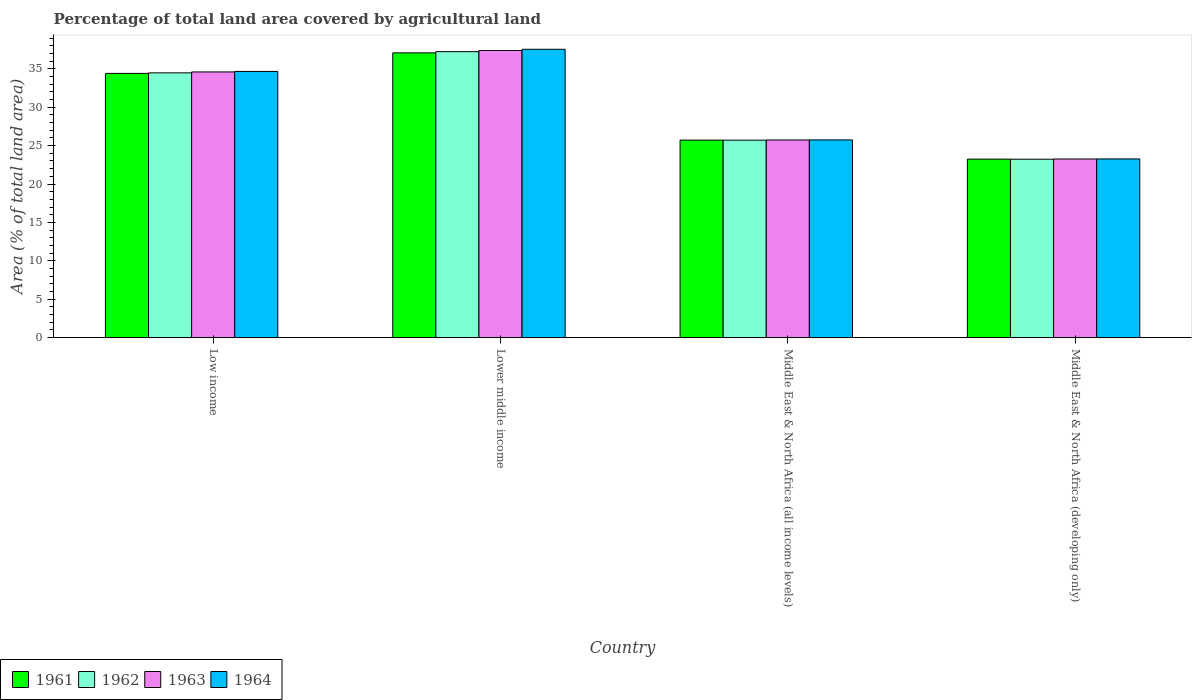Are the number of bars per tick equal to the number of legend labels?
Make the answer very short. Yes. Are the number of bars on each tick of the X-axis equal?
Keep it short and to the point. Yes. How many bars are there on the 1st tick from the right?
Give a very brief answer. 4. What is the label of the 3rd group of bars from the left?
Your response must be concise. Middle East & North Africa (all income levels). In how many cases, is the number of bars for a given country not equal to the number of legend labels?
Your answer should be compact. 0. What is the percentage of agricultural land in 1962 in Middle East & North Africa (developing only)?
Make the answer very short. 23.23. Across all countries, what is the maximum percentage of agricultural land in 1961?
Offer a very short reply. 37.07. Across all countries, what is the minimum percentage of agricultural land in 1961?
Your response must be concise. 23.24. In which country was the percentage of agricultural land in 1961 maximum?
Provide a succinct answer. Lower middle income. In which country was the percentage of agricultural land in 1961 minimum?
Offer a terse response. Middle East & North Africa (developing only). What is the total percentage of agricultural land in 1964 in the graph?
Offer a very short reply. 121.2. What is the difference between the percentage of agricultural land in 1961 in Lower middle income and that in Middle East & North Africa (developing only)?
Your response must be concise. 13.83. What is the difference between the percentage of agricultural land in 1963 in Low income and the percentage of agricultural land in 1961 in Middle East & North Africa (developing only)?
Offer a very short reply. 11.35. What is the average percentage of agricultural land in 1963 per country?
Offer a very short reply. 30.24. What is the difference between the percentage of agricultural land of/in 1962 and percentage of agricultural land of/in 1964 in Middle East & North Africa (all income levels)?
Your response must be concise. -0.03. In how many countries, is the percentage of agricultural land in 1963 greater than 23 %?
Offer a terse response. 4. What is the ratio of the percentage of agricultural land in 1964 in Low income to that in Middle East & North Africa (developing only)?
Your answer should be very brief. 1.49. Is the difference between the percentage of agricultural land in 1962 in Low income and Middle East & North Africa (all income levels) greater than the difference between the percentage of agricultural land in 1964 in Low income and Middle East & North Africa (all income levels)?
Keep it short and to the point. No. What is the difference between the highest and the second highest percentage of agricultural land in 1961?
Provide a short and direct response. -8.68. What is the difference between the highest and the lowest percentage of agricultural land in 1964?
Your answer should be compact. 14.27. In how many countries, is the percentage of agricultural land in 1963 greater than the average percentage of agricultural land in 1963 taken over all countries?
Your response must be concise. 2. Is the sum of the percentage of agricultural land in 1963 in Low income and Middle East & North Africa (all income levels) greater than the maximum percentage of agricultural land in 1961 across all countries?
Your answer should be compact. Yes. Is it the case that in every country, the sum of the percentage of agricultural land in 1964 and percentage of agricultural land in 1963 is greater than the sum of percentage of agricultural land in 1961 and percentage of agricultural land in 1962?
Give a very brief answer. No. What does the 1st bar from the left in Middle East & North Africa (all income levels) represents?
Keep it short and to the point. 1961. What does the 3rd bar from the right in Middle East & North Africa (all income levels) represents?
Your answer should be compact. 1962. Is it the case that in every country, the sum of the percentage of agricultural land in 1964 and percentage of agricultural land in 1962 is greater than the percentage of agricultural land in 1961?
Give a very brief answer. Yes. What is the difference between two consecutive major ticks on the Y-axis?
Your answer should be compact. 5. Are the values on the major ticks of Y-axis written in scientific E-notation?
Your response must be concise. No. Does the graph contain any zero values?
Ensure brevity in your answer.  No. Where does the legend appear in the graph?
Give a very brief answer. Bottom left. What is the title of the graph?
Your response must be concise. Percentage of total land area covered by agricultural land. What is the label or title of the Y-axis?
Give a very brief answer. Area (% of total land area). What is the Area (% of total land area) in 1961 in Low income?
Ensure brevity in your answer.  34.4. What is the Area (% of total land area) of 1962 in Low income?
Your response must be concise. 34.47. What is the Area (% of total land area) of 1963 in Low income?
Your answer should be compact. 34.59. What is the Area (% of total land area) of 1964 in Low income?
Your answer should be very brief. 34.66. What is the Area (% of total land area) in 1961 in Lower middle income?
Your response must be concise. 37.07. What is the Area (% of total land area) in 1962 in Lower middle income?
Your answer should be very brief. 37.23. What is the Area (% of total land area) in 1963 in Lower middle income?
Provide a succinct answer. 37.38. What is the Area (% of total land area) in 1964 in Lower middle income?
Keep it short and to the point. 37.54. What is the Area (% of total land area) of 1961 in Middle East & North Africa (all income levels)?
Your answer should be compact. 25.72. What is the Area (% of total land area) in 1962 in Middle East & North Africa (all income levels)?
Provide a short and direct response. 25.71. What is the Area (% of total land area) of 1963 in Middle East & North Africa (all income levels)?
Ensure brevity in your answer.  25.73. What is the Area (% of total land area) of 1964 in Middle East & North Africa (all income levels)?
Offer a very short reply. 25.74. What is the Area (% of total land area) of 1961 in Middle East & North Africa (developing only)?
Offer a very short reply. 23.24. What is the Area (% of total land area) of 1962 in Middle East & North Africa (developing only)?
Keep it short and to the point. 23.23. What is the Area (% of total land area) in 1963 in Middle East & North Africa (developing only)?
Your answer should be very brief. 23.26. What is the Area (% of total land area) of 1964 in Middle East & North Africa (developing only)?
Keep it short and to the point. 23.26. Across all countries, what is the maximum Area (% of total land area) of 1961?
Your response must be concise. 37.07. Across all countries, what is the maximum Area (% of total land area) in 1962?
Offer a very short reply. 37.23. Across all countries, what is the maximum Area (% of total land area) of 1963?
Keep it short and to the point. 37.38. Across all countries, what is the maximum Area (% of total land area) of 1964?
Your answer should be very brief. 37.54. Across all countries, what is the minimum Area (% of total land area) in 1961?
Make the answer very short. 23.24. Across all countries, what is the minimum Area (% of total land area) of 1962?
Ensure brevity in your answer.  23.23. Across all countries, what is the minimum Area (% of total land area) in 1963?
Your answer should be very brief. 23.26. Across all countries, what is the minimum Area (% of total land area) of 1964?
Provide a succinct answer. 23.26. What is the total Area (% of total land area) of 1961 in the graph?
Your response must be concise. 120.43. What is the total Area (% of total land area) in 1962 in the graph?
Your answer should be compact. 120.64. What is the total Area (% of total land area) in 1963 in the graph?
Make the answer very short. 120.96. What is the total Area (% of total land area) in 1964 in the graph?
Make the answer very short. 121.2. What is the difference between the Area (% of total land area) in 1961 in Low income and that in Lower middle income?
Offer a terse response. -2.67. What is the difference between the Area (% of total land area) in 1962 in Low income and that in Lower middle income?
Offer a very short reply. -2.77. What is the difference between the Area (% of total land area) in 1963 in Low income and that in Lower middle income?
Your answer should be very brief. -2.79. What is the difference between the Area (% of total land area) in 1964 in Low income and that in Lower middle income?
Keep it short and to the point. -2.88. What is the difference between the Area (% of total land area) of 1961 in Low income and that in Middle East & North Africa (all income levels)?
Ensure brevity in your answer.  8.68. What is the difference between the Area (% of total land area) of 1962 in Low income and that in Middle East & North Africa (all income levels)?
Keep it short and to the point. 8.76. What is the difference between the Area (% of total land area) of 1963 in Low income and that in Middle East & North Africa (all income levels)?
Keep it short and to the point. 8.85. What is the difference between the Area (% of total land area) of 1964 in Low income and that in Middle East & North Africa (all income levels)?
Offer a very short reply. 8.91. What is the difference between the Area (% of total land area) in 1961 in Low income and that in Middle East & North Africa (developing only)?
Provide a succinct answer. 11.16. What is the difference between the Area (% of total land area) of 1962 in Low income and that in Middle East & North Africa (developing only)?
Ensure brevity in your answer.  11.24. What is the difference between the Area (% of total land area) of 1963 in Low income and that in Middle East & North Africa (developing only)?
Give a very brief answer. 11.33. What is the difference between the Area (% of total land area) in 1964 in Low income and that in Middle East & North Africa (developing only)?
Your answer should be very brief. 11.39. What is the difference between the Area (% of total land area) of 1961 in Lower middle income and that in Middle East & North Africa (all income levels)?
Offer a terse response. 11.36. What is the difference between the Area (% of total land area) of 1962 in Lower middle income and that in Middle East & North Africa (all income levels)?
Offer a terse response. 11.52. What is the difference between the Area (% of total land area) of 1963 in Lower middle income and that in Middle East & North Africa (all income levels)?
Your response must be concise. 11.65. What is the difference between the Area (% of total land area) in 1964 in Lower middle income and that in Middle East & North Africa (all income levels)?
Your answer should be very brief. 11.8. What is the difference between the Area (% of total land area) of 1961 in Lower middle income and that in Middle East & North Africa (developing only)?
Your answer should be compact. 13.83. What is the difference between the Area (% of total land area) in 1962 in Lower middle income and that in Middle East & North Africa (developing only)?
Make the answer very short. 14. What is the difference between the Area (% of total land area) in 1963 in Lower middle income and that in Middle East & North Africa (developing only)?
Your response must be concise. 14.12. What is the difference between the Area (% of total land area) in 1964 in Lower middle income and that in Middle East & North Africa (developing only)?
Provide a succinct answer. 14.27. What is the difference between the Area (% of total land area) of 1961 in Middle East & North Africa (all income levels) and that in Middle East & North Africa (developing only)?
Your answer should be very brief. 2.48. What is the difference between the Area (% of total land area) in 1962 in Middle East & North Africa (all income levels) and that in Middle East & North Africa (developing only)?
Offer a very short reply. 2.48. What is the difference between the Area (% of total land area) of 1963 in Middle East & North Africa (all income levels) and that in Middle East & North Africa (developing only)?
Your answer should be compact. 2.48. What is the difference between the Area (% of total land area) in 1964 in Middle East & North Africa (all income levels) and that in Middle East & North Africa (developing only)?
Provide a short and direct response. 2.48. What is the difference between the Area (% of total land area) in 1961 in Low income and the Area (% of total land area) in 1962 in Lower middle income?
Your response must be concise. -2.83. What is the difference between the Area (% of total land area) in 1961 in Low income and the Area (% of total land area) in 1963 in Lower middle income?
Your response must be concise. -2.98. What is the difference between the Area (% of total land area) in 1961 in Low income and the Area (% of total land area) in 1964 in Lower middle income?
Provide a short and direct response. -3.14. What is the difference between the Area (% of total land area) of 1962 in Low income and the Area (% of total land area) of 1963 in Lower middle income?
Keep it short and to the point. -2.91. What is the difference between the Area (% of total land area) of 1962 in Low income and the Area (% of total land area) of 1964 in Lower middle income?
Make the answer very short. -3.07. What is the difference between the Area (% of total land area) in 1963 in Low income and the Area (% of total land area) in 1964 in Lower middle income?
Your answer should be compact. -2.95. What is the difference between the Area (% of total land area) in 1961 in Low income and the Area (% of total land area) in 1962 in Middle East & North Africa (all income levels)?
Keep it short and to the point. 8.69. What is the difference between the Area (% of total land area) in 1961 in Low income and the Area (% of total land area) in 1963 in Middle East & North Africa (all income levels)?
Offer a very short reply. 8.67. What is the difference between the Area (% of total land area) in 1961 in Low income and the Area (% of total land area) in 1964 in Middle East & North Africa (all income levels)?
Offer a terse response. 8.66. What is the difference between the Area (% of total land area) in 1962 in Low income and the Area (% of total land area) in 1963 in Middle East & North Africa (all income levels)?
Give a very brief answer. 8.73. What is the difference between the Area (% of total land area) of 1962 in Low income and the Area (% of total land area) of 1964 in Middle East & North Africa (all income levels)?
Offer a terse response. 8.73. What is the difference between the Area (% of total land area) of 1963 in Low income and the Area (% of total land area) of 1964 in Middle East & North Africa (all income levels)?
Give a very brief answer. 8.85. What is the difference between the Area (% of total land area) of 1961 in Low income and the Area (% of total land area) of 1962 in Middle East & North Africa (developing only)?
Ensure brevity in your answer.  11.17. What is the difference between the Area (% of total land area) in 1961 in Low income and the Area (% of total land area) in 1963 in Middle East & North Africa (developing only)?
Give a very brief answer. 11.14. What is the difference between the Area (% of total land area) in 1961 in Low income and the Area (% of total land area) in 1964 in Middle East & North Africa (developing only)?
Make the answer very short. 11.14. What is the difference between the Area (% of total land area) in 1962 in Low income and the Area (% of total land area) in 1963 in Middle East & North Africa (developing only)?
Your answer should be very brief. 11.21. What is the difference between the Area (% of total land area) in 1962 in Low income and the Area (% of total land area) in 1964 in Middle East & North Africa (developing only)?
Provide a short and direct response. 11.2. What is the difference between the Area (% of total land area) in 1963 in Low income and the Area (% of total land area) in 1964 in Middle East & North Africa (developing only)?
Offer a terse response. 11.32. What is the difference between the Area (% of total land area) of 1961 in Lower middle income and the Area (% of total land area) of 1962 in Middle East & North Africa (all income levels)?
Offer a very short reply. 11.36. What is the difference between the Area (% of total land area) of 1961 in Lower middle income and the Area (% of total land area) of 1963 in Middle East & North Africa (all income levels)?
Provide a succinct answer. 11.34. What is the difference between the Area (% of total land area) of 1961 in Lower middle income and the Area (% of total land area) of 1964 in Middle East & North Africa (all income levels)?
Offer a terse response. 11.33. What is the difference between the Area (% of total land area) of 1962 in Lower middle income and the Area (% of total land area) of 1963 in Middle East & North Africa (all income levels)?
Make the answer very short. 11.5. What is the difference between the Area (% of total land area) in 1962 in Lower middle income and the Area (% of total land area) in 1964 in Middle East & North Africa (all income levels)?
Offer a very short reply. 11.49. What is the difference between the Area (% of total land area) in 1963 in Lower middle income and the Area (% of total land area) in 1964 in Middle East & North Africa (all income levels)?
Your answer should be very brief. 11.64. What is the difference between the Area (% of total land area) of 1961 in Lower middle income and the Area (% of total land area) of 1962 in Middle East & North Africa (developing only)?
Your response must be concise. 13.85. What is the difference between the Area (% of total land area) of 1961 in Lower middle income and the Area (% of total land area) of 1963 in Middle East & North Africa (developing only)?
Make the answer very short. 13.82. What is the difference between the Area (% of total land area) in 1961 in Lower middle income and the Area (% of total land area) in 1964 in Middle East & North Africa (developing only)?
Provide a succinct answer. 13.81. What is the difference between the Area (% of total land area) of 1962 in Lower middle income and the Area (% of total land area) of 1963 in Middle East & North Africa (developing only)?
Your response must be concise. 13.98. What is the difference between the Area (% of total land area) in 1962 in Lower middle income and the Area (% of total land area) in 1964 in Middle East & North Africa (developing only)?
Offer a terse response. 13.97. What is the difference between the Area (% of total land area) of 1963 in Lower middle income and the Area (% of total land area) of 1964 in Middle East & North Africa (developing only)?
Give a very brief answer. 14.12. What is the difference between the Area (% of total land area) of 1961 in Middle East & North Africa (all income levels) and the Area (% of total land area) of 1962 in Middle East & North Africa (developing only)?
Your answer should be very brief. 2.49. What is the difference between the Area (% of total land area) of 1961 in Middle East & North Africa (all income levels) and the Area (% of total land area) of 1963 in Middle East & North Africa (developing only)?
Offer a very short reply. 2.46. What is the difference between the Area (% of total land area) in 1961 in Middle East & North Africa (all income levels) and the Area (% of total land area) in 1964 in Middle East & North Africa (developing only)?
Offer a very short reply. 2.45. What is the difference between the Area (% of total land area) in 1962 in Middle East & North Africa (all income levels) and the Area (% of total land area) in 1963 in Middle East & North Africa (developing only)?
Your answer should be very brief. 2.45. What is the difference between the Area (% of total land area) of 1962 in Middle East & North Africa (all income levels) and the Area (% of total land area) of 1964 in Middle East & North Africa (developing only)?
Provide a short and direct response. 2.45. What is the difference between the Area (% of total land area) of 1963 in Middle East & North Africa (all income levels) and the Area (% of total land area) of 1964 in Middle East & North Africa (developing only)?
Make the answer very short. 2.47. What is the average Area (% of total land area) in 1961 per country?
Your answer should be compact. 30.11. What is the average Area (% of total land area) in 1962 per country?
Your answer should be very brief. 30.16. What is the average Area (% of total land area) of 1963 per country?
Give a very brief answer. 30.24. What is the average Area (% of total land area) of 1964 per country?
Your response must be concise. 30.3. What is the difference between the Area (% of total land area) in 1961 and Area (% of total land area) in 1962 in Low income?
Your answer should be compact. -0.07. What is the difference between the Area (% of total land area) of 1961 and Area (% of total land area) of 1963 in Low income?
Provide a succinct answer. -0.19. What is the difference between the Area (% of total land area) of 1961 and Area (% of total land area) of 1964 in Low income?
Offer a very short reply. -0.26. What is the difference between the Area (% of total land area) of 1962 and Area (% of total land area) of 1963 in Low income?
Make the answer very short. -0.12. What is the difference between the Area (% of total land area) in 1962 and Area (% of total land area) in 1964 in Low income?
Your answer should be compact. -0.19. What is the difference between the Area (% of total land area) of 1963 and Area (% of total land area) of 1964 in Low income?
Keep it short and to the point. -0.07. What is the difference between the Area (% of total land area) in 1961 and Area (% of total land area) in 1962 in Lower middle income?
Your response must be concise. -0.16. What is the difference between the Area (% of total land area) in 1961 and Area (% of total land area) in 1963 in Lower middle income?
Your answer should be very brief. -0.31. What is the difference between the Area (% of total land area) in 1961 and Area (% of total land area) in 1964 in Lower middle income?
Provide a succinct answer. -0.46. What is the difference between the Area (% of total land area) of 1962 and Area (% of total land area) of 1963 in Lower middle income?
Your answer should be compact. -0.15. What is the difference between the Area (% of total land area) in 1962 and Area (% of total land area) in 1964 in Lower middle income?
Make the answer very short. -0.3. What is the difference between the Area (% of total land area) of 1963 and Area (% of total land area) of 1964 in Lower middle income?
Offer a very short reply. -0.16. What is the difference between the Area (% of total land area) of 1961 and Area (% of total land area) of 1962 in Middle East & North Africa (all income levels)?
Your answer should be very brief. 0.01. What is the difference between the Area (% of total land area) of 1961 and Area (% of total land area) of 1963 in Middle East & North Africa (all income levels)?
Keep it short and to the point. -0.02. What is the difference between the Area (% of total land area) of 1961 and Area (% of total land area) of 1964 in Middle East & North Africa (all income levels)?
Ensure brevity in your answer.  -0.02. What is the difference between the Area (% of total land area) in 1962 and Area (% of total land area) in 1963 in Middle East & North Africa (all income levels)?
Make the answer very short. -0.03. What is the difference between the Area (% of total land area) in 1962 and Area (% of total land area) in 1964 in Middle East & North Africa (all income levels)?
Give a very brief answer. -0.03. What is the difference between the Area (% of total land area) in 1963 and Area (% of total land area) in 1964 in Middle East & North Africa (all income levels)?
Make the answer very short. -0.01. What is the difference between the Area (% of total land area) of 1961 and Area (% of total land area) of 1962 in Middle East & North Africa (developing only)?
Provide a short and direct response. 0.01. What is the difference between the Area (% of total land area) in 1961 and Area (% of total land area) in 1963 in Middle East & North Africa (developing only)?
Your answer should be very brief. -0.02. What is the difference between the Area (% of total land area) in 1961 and Area (% of total land area) in 1964 in Middle East & North Africa (developing only)?
Your response must be concise. -0.02. What is the difference between the Area (% of total land area) of 1962 and Area (% of total land area) of 1963 in Middle East & North Africa (developing only)?
Provide a succinct answer. -0.03. What is the difference between the Area (% of total land area) of 1962 and Area (% of total land area) of 1964 in Middle East & North Africa (developing only)?
Give a very brief answer. -0.03. What is the difference between the Area (% of total land area) of 1963 and Area (% of total land area) of 1964 in Middle East & North Africa (developing only)?
Your response must be concise. -0.01. What is the ratio of the Area (% of total land area) of 1961 in Low income to that in Lower middle income?
Your response must be concise. 0.93. What is the ratio of the Area (% of total land area) in 1962 in Low income to that in Lower middle income?
Offer a very short reply. 0.93. What is the ratio of the Area (% of total land area) in 1963 in Low income to that in Lower middle income?
Make the answer very short. 0.93. What is the ratio of the Area (% of total land area) of 1964 in Low income to that in Lower middle income?
Ensure brevity in your answer.  0.92. What is the ratio of the Area (% of total land area) in 1961 in Low income to that in Middle East & North Africa (all income levels)?
Keep it short and to the point. 1.34. What is the ratio of the Area (% of total land area) in 1962 in Low income to that in Middle East & North Africa (all income levels)?
Keep it short and to the point. 1.34. What is the ratio of the Area (% of total land area) in 1963 in Low income to that in Middle East & North Africa (all income levels)?
Provide a succinct answer. 1.34. What is the ratio of the Area (% of total land area) of 1964 in Low income to that in Middle East & North Africa (all income levels)?
Make the answer very short. 1.35. What is the ratio of the Area (% of total land area) in 1961 in Low income to that in Middle East & North Africa (developing only)?
Keep it short and to the point. 1.48. What is the ratio of the Area (% of total land area) of 1962 in Low income to that in Middle East & North Africa (developing only)?
Ensure brevity in your answer.  1.48. What is the ratio of the Area (% of total land area) in 1963 in Low income to that in Middle East & North Africa (developing only)?
Your answer should be very brief. 1.49. What is the ratio of the Area (% of total land area) of 1964 in Low income to that in Middle East & North Africa (developing only)?
Your answer should be compact. 1.49. What is the ratio of the Area (% of total land area) in 1961 in Lower middle income to that in Middle East & North Africa (all income levels)?
Make the answer very short. 1.44. What is the ratio of the Area (% of total land area) in 1962 in Lower middle income to that in Middle East & North Africa (all income levels)?
Your answer should be very brief. 1.45. What is the ratio of the Area (% of total land area) of 1963 in Lower middle income to that in Middle East & North Africa (all income levels)?
Offer a terse response. 1.45. What is the ratio of the Area (% of total land area) of 1964 in Lower middle income to that in Middle East & North Africa (all income levels)?
Ensure brevity in your answer.  1.46. What is the ratio of the Area (% of total land area) in 1961 in Lower middle income to that in Middle East & North Africa (developing only)?
Give a very brief answer. 1.6. What is the ratio of the Area (% of total land area) in 1962 in Lower middle income to that in Middle East & North Africa (developing only)?
Offer a very short reply. 1.6. What is the ratio of the Area (% of total land area) in 1963 in Lower middle income to that in Middle East & North Africa (developing only)?
Provide a short and direct response. 1.61. What is the ratio of the Area (% of total land area) of 1964 in Lower middle income to that in Middle East & North Africa (developing only)?
Your response must be concise. 1.61. What is the ratio of the Area (% of total land area) of 1961 in Middle East & North Africa (all income levels) to that in Middle East & North Africa (developing only)?
Your response must be concise. 1.11. What is the ratio of the Area (% of total land area) of 1962 in Middle East & North Africa (all income levels) to that in Middle East & North Africa (developing only)?
Provide a succinct answer. 1.11. What is the ratio of the Area (% of total land area) of 1963 in Middle East & North Africa (all income levels) to that in Middle East & North Africa (developing only)?
Your response must be concise. 1.11. What is the ratio of the Area (% of total land area) in 1964 in Middle East & North Africa (all income levels) to that in Middle East & North Africa (developing only)?
Provide a short and direct response. 1.11. What is the difference between the highest and the second highest Area (% of total land area) of 1961?
Give a very brief answer. 2.67. What is the difference between the highest and the second highest Area (% of total land area) of 1962?
Your response must be concise. 2.77. What is the difference between the highest and the second highest Area (% of total land area) in 1963?
Ensure brevity in your answer.  2.79. What is the difference between the highest and the second highest Area (% of total land area) of 1964?
Give a very brief answer. 2.88. What is the difference between the highest and the lowest Area (% of total land area) of 1961?
Your answer should be very brief. 13.83. What is the difference between the highest and the lowest Area (% of total land area) of 1962?
Provide a short and direct response. 14. What is the difference between the highest and the lowest Area (% of total land area) of 1963?
Keep it short and to the point. 14.12. What is the difference between the highest and the lowest Area (% of total land area) of 1964?
Offer a very short reply. 14.27. 